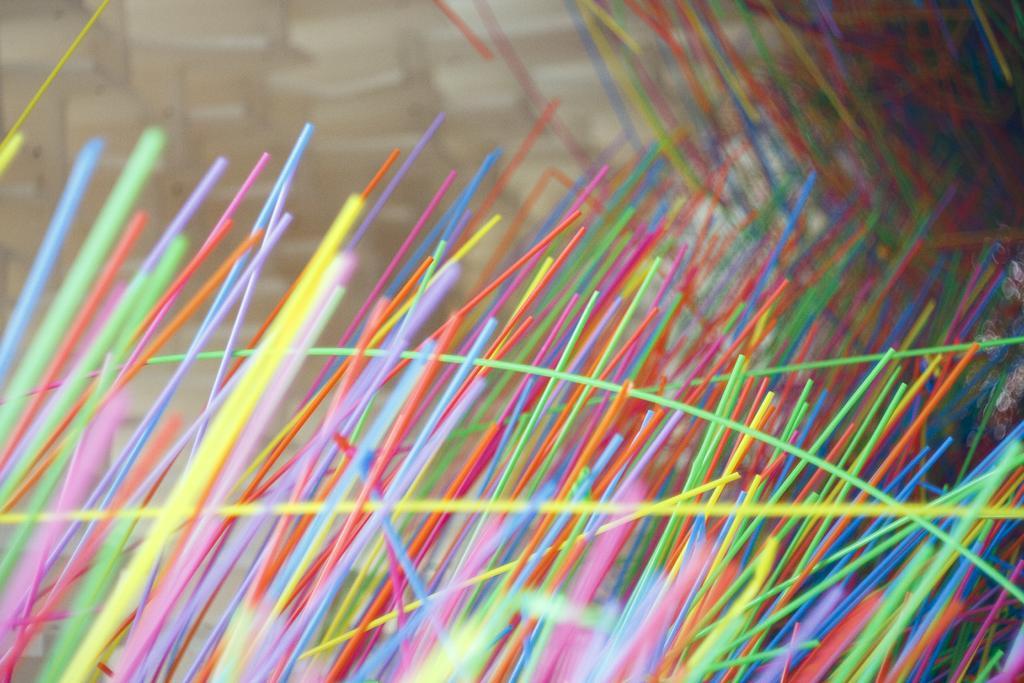How would you summarize this image in a sentence or two? In this image we can see colorful sticks. 